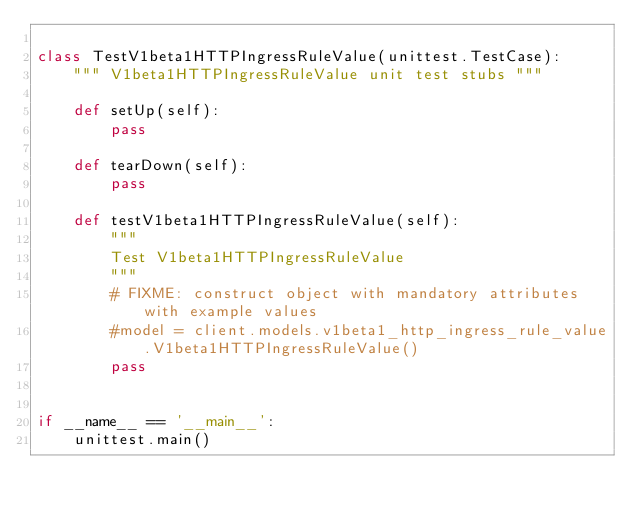<code> <loc_0><loc_0><loc_500><loc_500><_Python_>
class TestV1beta1HTTPIngressRuleValue(unittest.TestCase):
    """ V1beta1HTTPIngressRuleValue unit test stubs """

    def setUp(self):
        pass

    def tearDown(self):
        pass

    def testV1beta1HTTPIngressRuleValue(self):
        """
        Test V1beta1HTTPIngressRuleValue
        """
        # FIXME: construct object with mandatory attributes with example values
        #model = client.models.v1beta1_http_ingress_rule_value.V1beta1HTTPIngressRuleValue()
        pass


if __name__ == '__main__':
    unittest.main()
</code> 